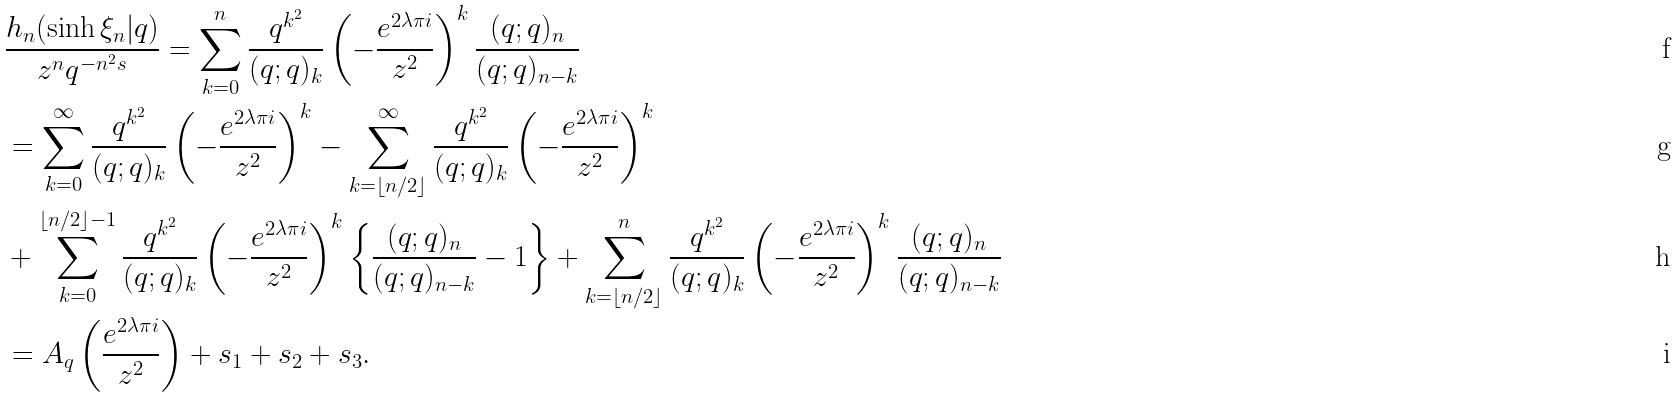<formula> <loc_0><loc_0><loc_500><loc_500>& \frac { h _ { n } ( \sinh \xi _ { n } | q ) } { z ^ { n } q ^ { - n ^ { 2 } s } } = \sum _ { k = 0 } ^ { n } \frac { q ^ { k ^ { 2 } } } { ( q ; q ) _ { k } } \left ( - \frac { e ^ { 2 \lambda \pi i } } { z ^ { 2 } } \right ) ^ { k } \frac { ( q ; q ) _ { n } } { ( q ; q ) _ { n - k } } \\ & = \sum _ { k = 0 } ^ { \infty } \frac { q ^ { k ^ { 2 } } } { ( q ; q ) _ { k } } \left ( - \frac { e ^ { 2 \lambda \pi i } } { z ^ { 2 } } \right ) ^ { k } - \sum _ { k = \left \lfloor n / 2 \right \rfloor } ^ { \infty } \frac { q ^ { k ^ { 2 } } } { ( q ; q ) _ { k } } \left ( - \frac { e ^ { 2 \lambda \pi i } } { z ^ { 2 } } \right ) ^ { k } \\ & + \sum _ { k = 0 } ^ { \left \lfloor n / 2 \right \rfloor - 1 } \frac { q ^ { k ^ { 2 } } } { ( q ; q ) _ { k } } \left ( - \frac { e ^ { 2 \lambda \pi i } } { z ^ { 2 } } \right ) ^ { k } \left \{ \frac { ( q ; q ) _ { n } } { ( q ; q ) _ { n - k } } - 1 \right \} + \sum _ { k = \left \lfloor n / 2 \right \rfloor } ^ { n } \frac { q ^ { k ^ { 2 } } } { ( q ; q ) _ { k } } \left ( - \frac { e ^ { 2 \lambda \pi i } } { z ^ { 2 } } \right ) ^ { k } \frac { ( q ; q ) _ { n } } { ( q ; q ) _ { n - k } } \\ & = A _ { q } \left ( \frac { e ^ { 2 \lambda \pi i } } { z ^ { 2 } } \right ) + s _ { 1 } + s _ { 2 } + s _ { 3 } .</formula> 